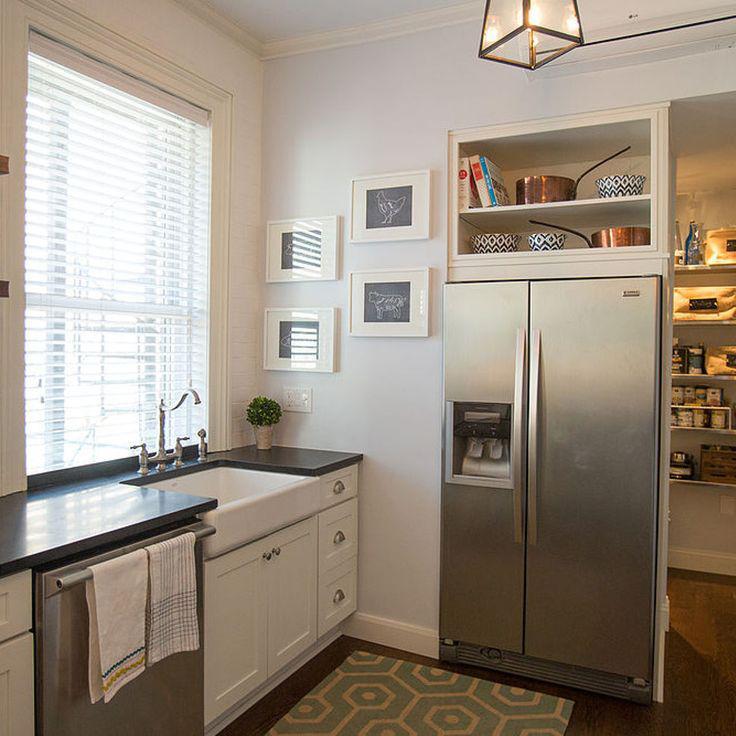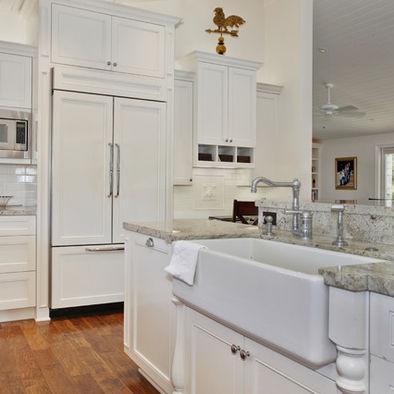The first image is the image on the left, the second image is the image on the right. Examine the images to the left and right. Is the description "An image shows a kitchen with white cabinets and a stainless steel refrigerator with """"french doors""""." accurate? Answer yes or no. Yes. The first image is the image on the left, the second image is the image on the right. For the images displayed, is the sentence "There is a stainless steel refrigerator  next to an entryway." factually correct? Answer yes or no. Yes. 